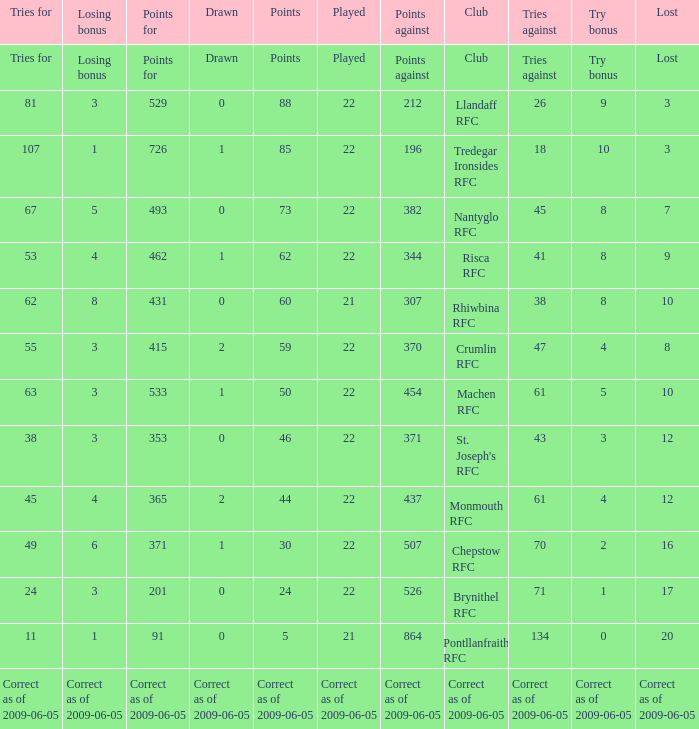If the Played was played, what is the lost? Lost. 